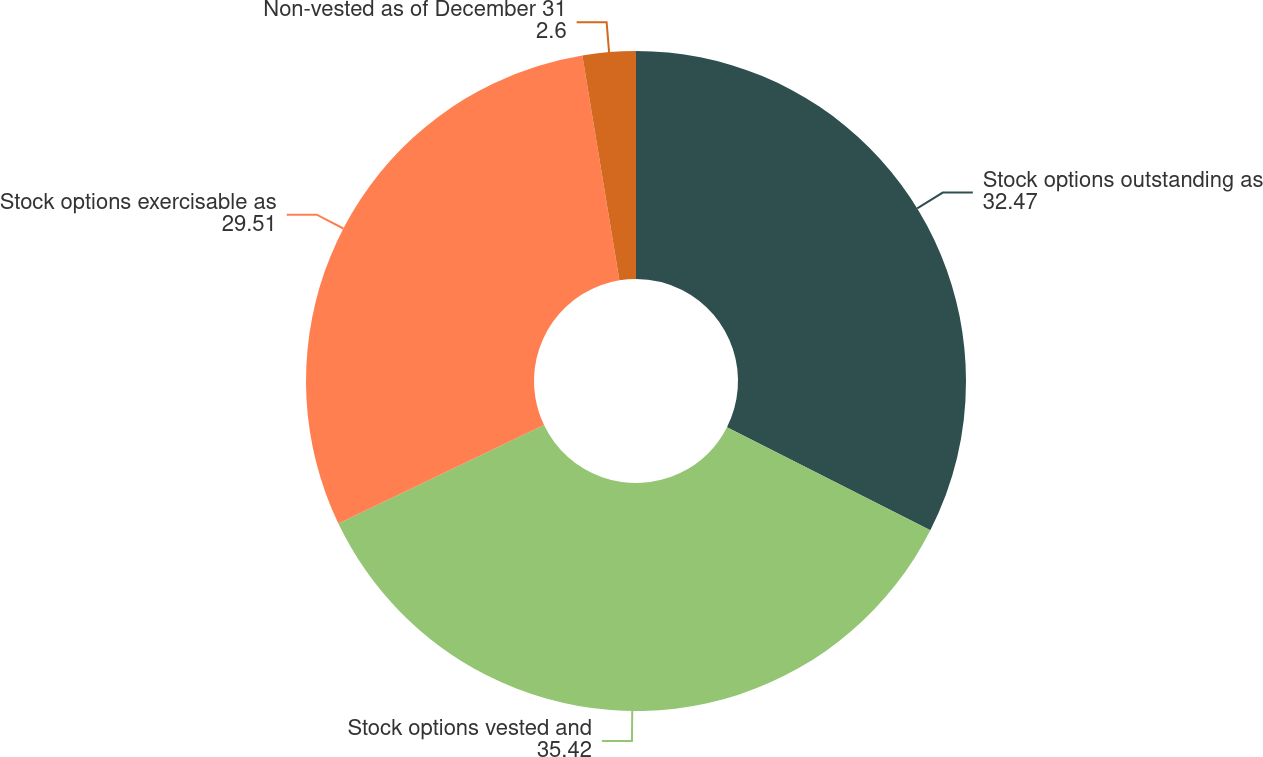Convert chart. <chart><loc_0><loc_0><loc_500><loc_500><pie_chart><fcel>Stock options outstanding as<fcel>Stock options vested and<fcel>Stock options exercisable as<fcel>Non-vested as of December 31<nl><fcel>32.47%<fcel>35.42%<fcel>29.51%<fcel>2.6%<nl></chart> 